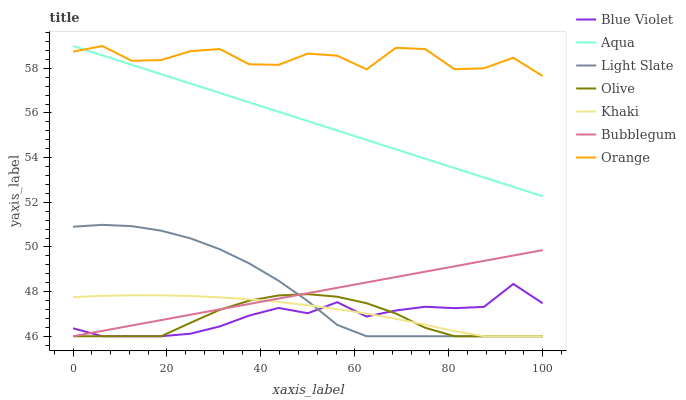Does Olive have the minimum area under the curve?
Answer yes or no. Yes. Does Orange have the maximum area under the curve?
Answer yes or no. Yes. Does Light Slate have the minimum area under the curve?
Answer yes or no. No. Does Light Slate have the maximum area under the curve?
Answer yes or no. No. Is Aqua the smoothest?
Answer yes or no. Yes. Is Orange the roughest?
Answer yes or no. Yes. Is Light Slate the smoothest?
Answer yes or no. No. Is Light Slate the roughest?
Answer yes or no. No. Does Aqua have the lowest value?
Answer yes or no. No. Does Orange have the highest value?
Answer yes or no. Yes. Does Light Slate have the highest value?
Answer yes or no. No. Is Blue Violet less than Aqua?
Answer yes or no. Yes. Is Orange greater than Light Slate?
Answer yes or no. Yes. Does Bubblegum intersect Olive?
Answer yes or no. Yes. Is Bubblegum less than Olive?
Answer yes or no. No. Is Bubblegum greater than Olive?
Answer yes or no. No. Does Blue Violet intersect Aqua?
Answer yes or no. No. 